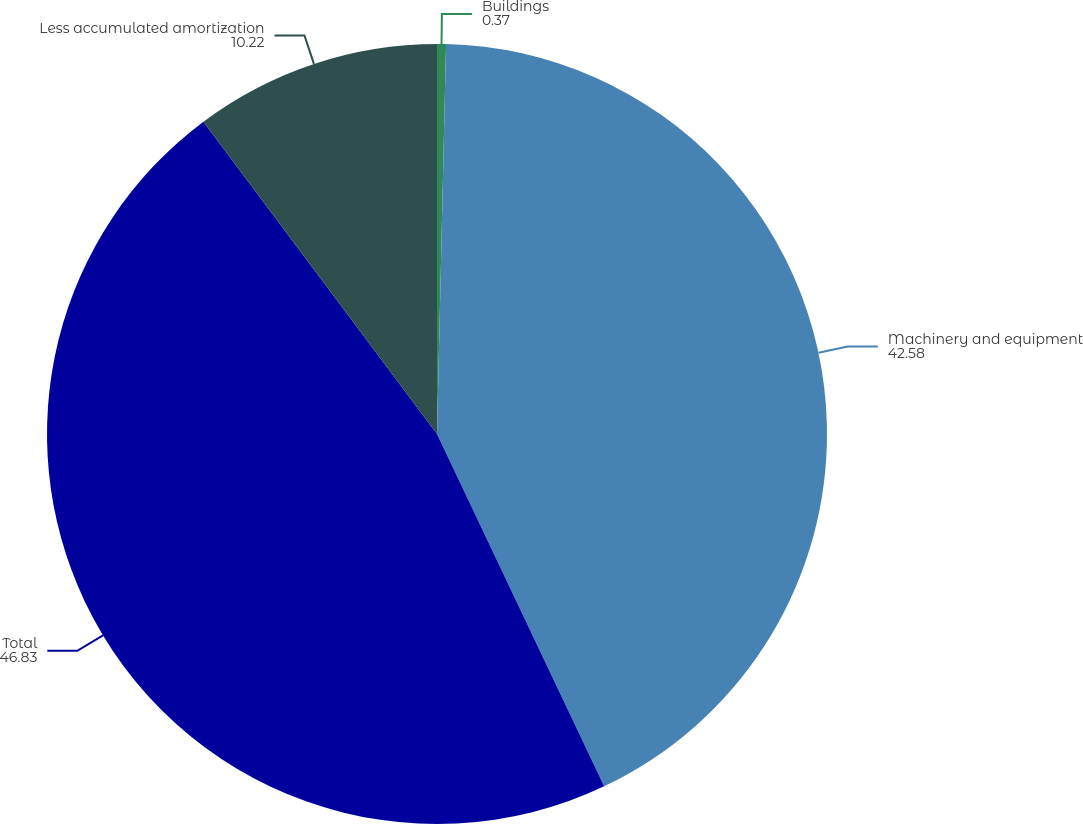<chart> <loc_0><loc_0><loc_500><loc_500><pie_chart><fcel>Buildings<fcel>Machinery and equipment<fcel>Total<fcel>Less accumulated amortization<nl><fcel>0.37%<fcel>42.58%<fcel>46.83%<fcel>10.22%<nl></chart> 